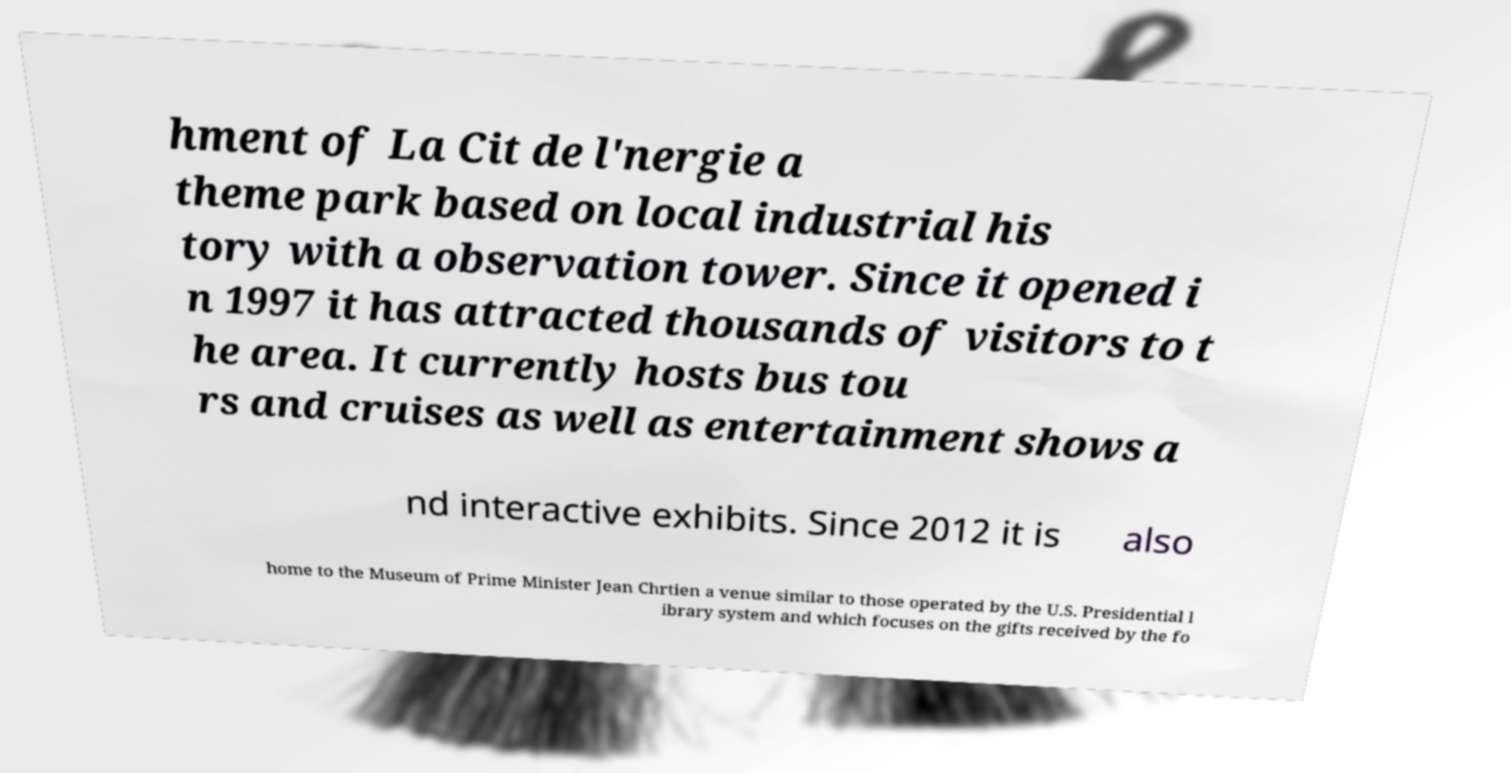Could you extract and type out the text from this image? hment of La Cit de l'nergie a theme park based on local industrial his tory with a observation tower. Since it opened i n 1997 it has attracted thousands of visitors to t he area. It currently hosts bus tou rs and cruises as well as entertainment shows a nd interactive exhibits. Since 2012 it is also home to the Museum of Prime Minister Jean Chrtien a venue similar to those operated by the U.S. Presidential l ibrary system and which focuses on the gifts received by the fo 